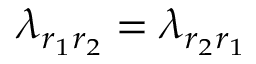Convert formula to latex. <formula><loc_0><loc_0><loc_500><loc_500>\lambda _ { r _ { 1 } r _ { 2 } } = \lambda _ { r _ { 2 } r _ { 1 } }</formula> 